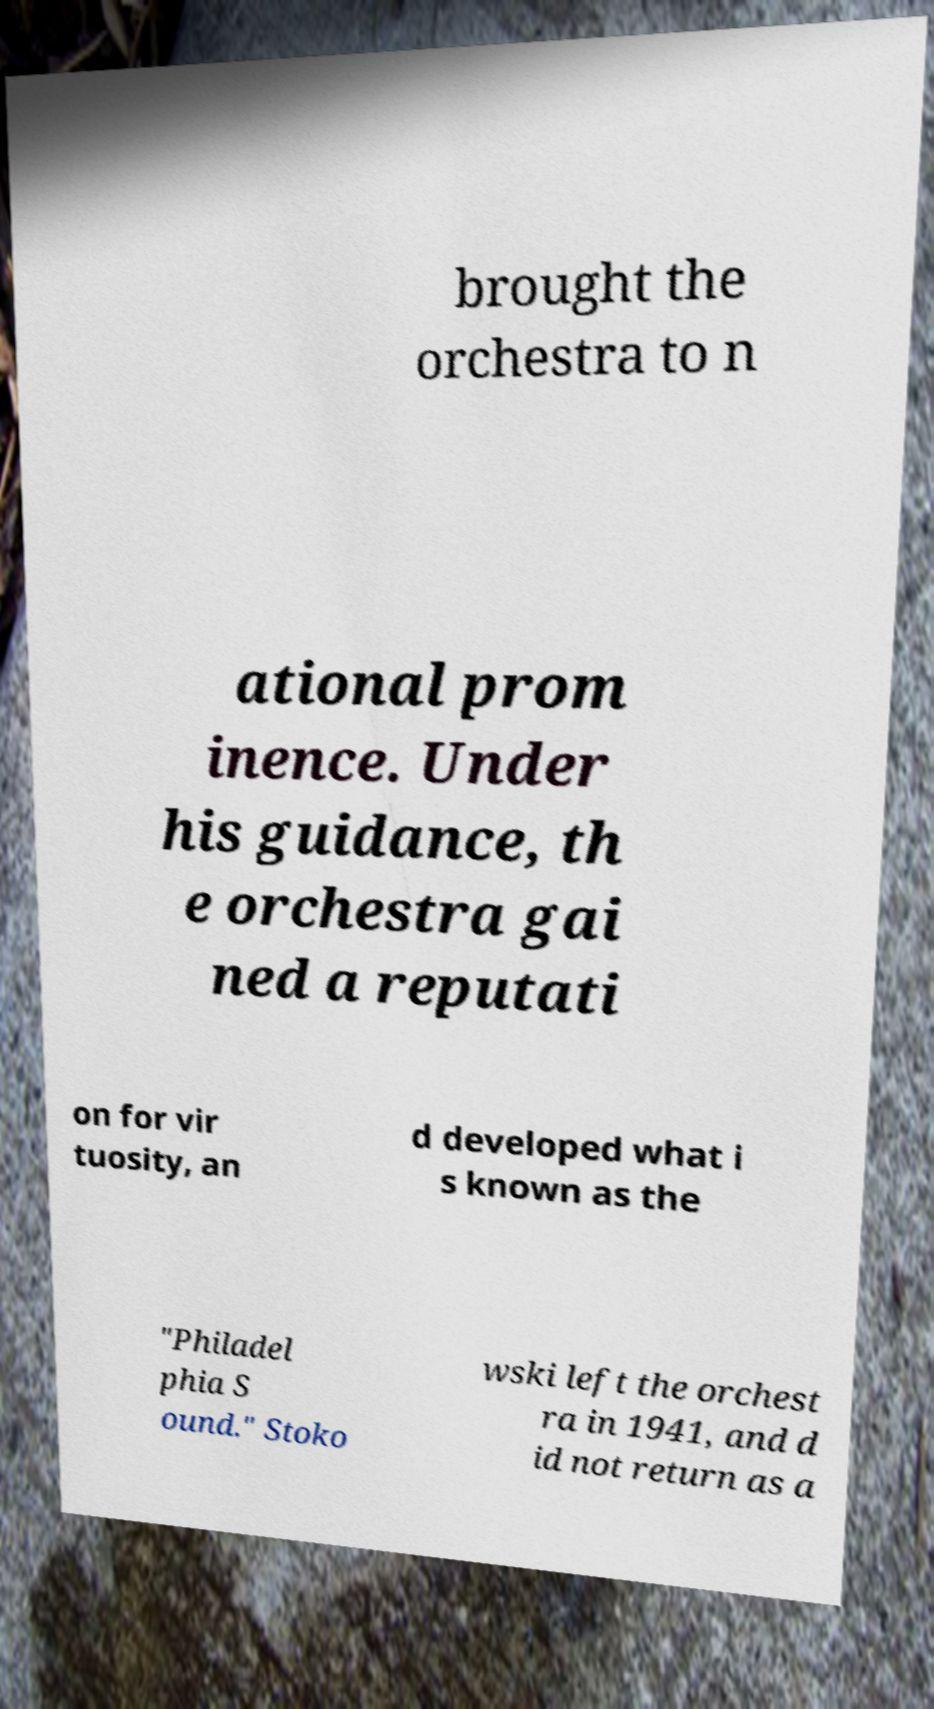What messages or text are displayed in this image? I need them in a readable, typed format. brought the orchestra to n ational prom inence. Under his guidance, th e orchestra gai ned a reputati on for vir tuosity, an d developed what i s known as the "Philadel phia S ound." Stoko wski left the orchest ra in 1941, and d id not return as a 